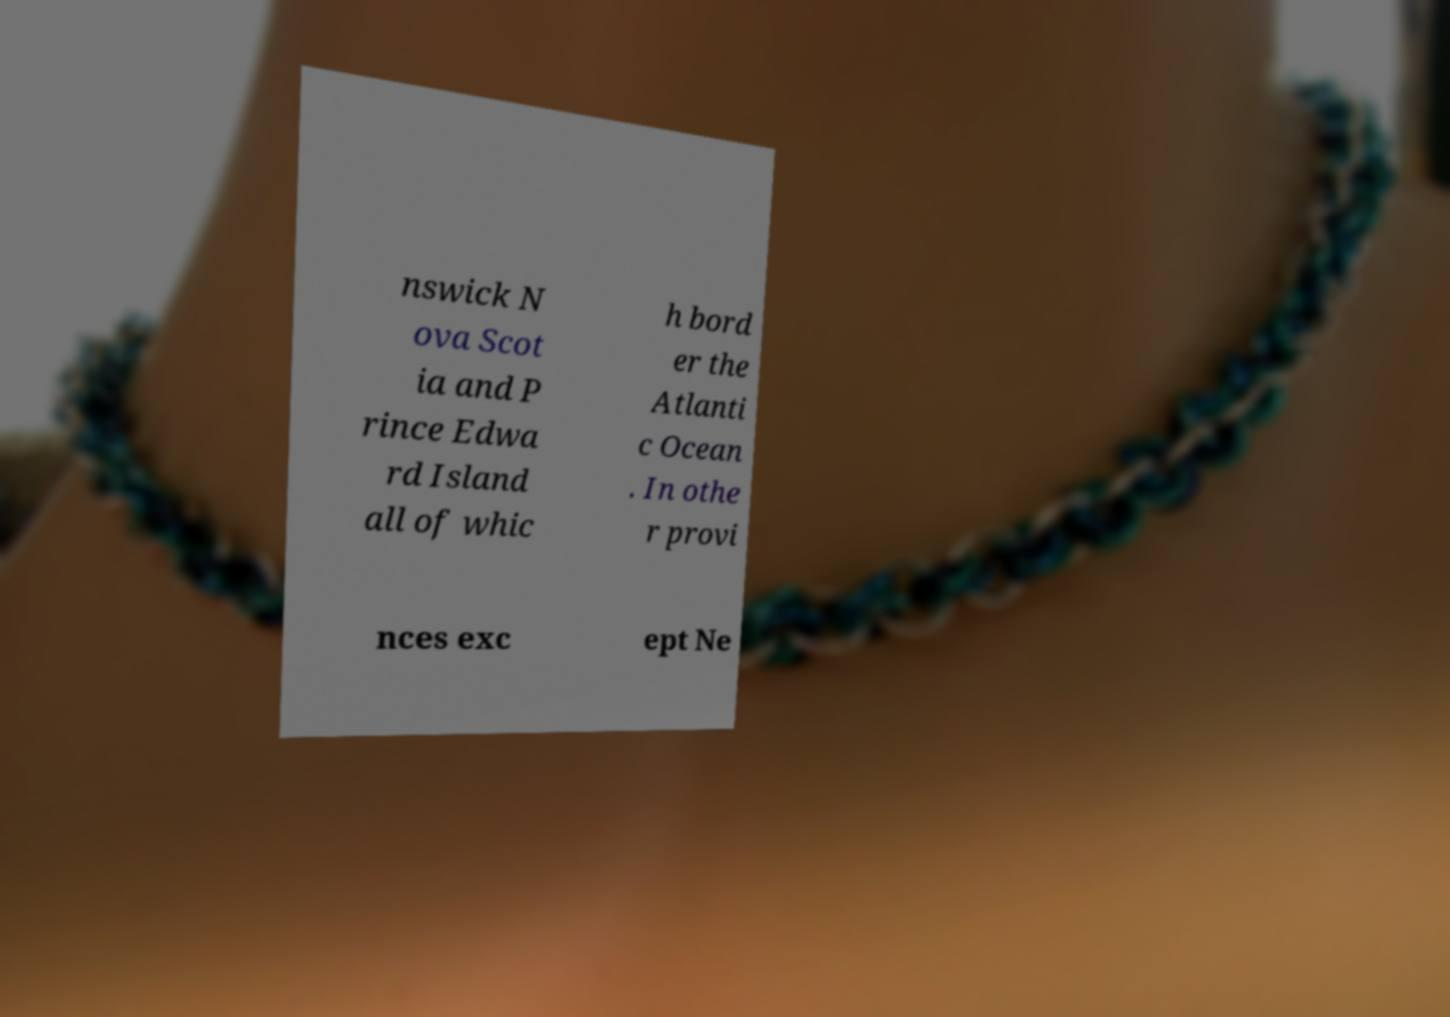For documentation purposes, I need the text within this image transcribed. Could you provide that? nswick N ova Scot ia and P rince Edwa rd Island all of whic h bord er the Atlanti c Ocean . In othe r provi nces exc ept Ne 